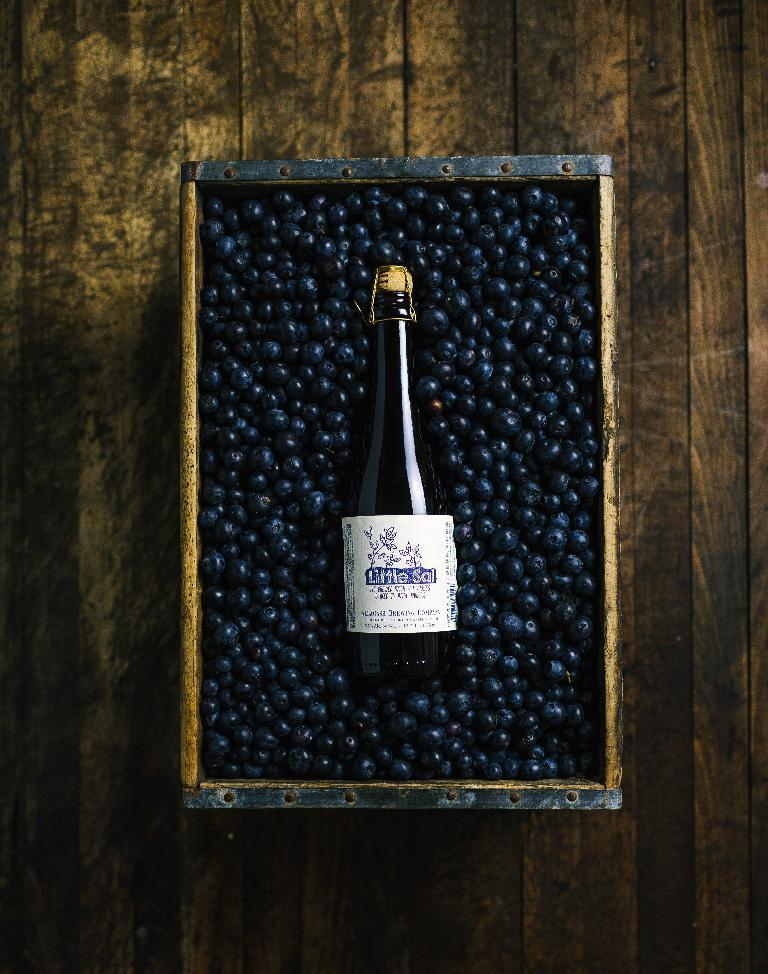What is the main object in the image? There is a container in the image. Where is the container located? The container is placed on a surface. What is inside the container? There are berries in the container. Is there any other object inside the container? Yes, there is a bottle in the container. What type of leaf is used as a credit card in the image? There is no leaf or credit card present in the image. Can you tell me how many basketballs are in the container? There are no basketballs present in the image; the container contains berries and a bottle. 